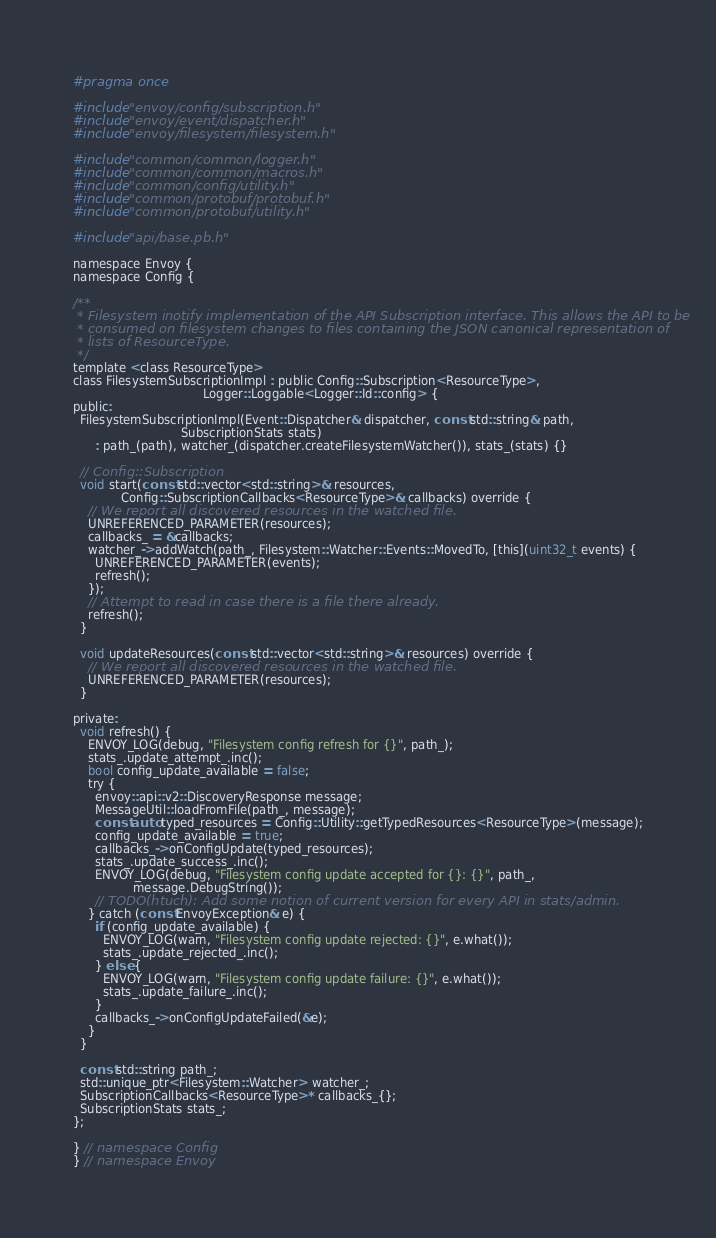Convert code to text. <code><loc_0><loc_0><loc_500><loc_500><_C_>#pragma once

#include "envoy/config/subscription.h"
#include "envoy/event/dispatcher.h"
#include "envoy/filesystem/filesystem.h"

#include "common/common/logger.h"
#include "common/common/macros.h"
#include "common/config/utility.h"
#include "common/protobuf/protobuf.h"
#include "common/protobuf/utility.h"

#include "api/base.pb.h"

namespace Envoy {
namespace Config {

/**
 * Filesystem inotify implementation of the API Subscription interface. This allows the API to be
 * consumed on filesystem changes to files containing the JSON canonical representation of
 * lists of ResourceType.
 */
template <class ResourceType>
class FilesystemSubscriptionImpl : public Config::Subscription<ResourceType>,
                                   Logger::Loggable<Logger::Id::config> {
public:
  FilesystemSubscriptionImpl(Event::Dispatcher& dispatcher, const std::string& path,
                             SubscriptionStats stats)
      : path_(path), watcher_(dispatcher.createFilesystemWatcher()), stats_(stats) {}

  // Config::Subscription
  void start(const std::vector<std::string>& resources,
             Config::SubscriptionCallbacks<ResourceType>& callbacks) override {
    // We report all discovered resources in the watched file.
    UNREFERENCED_PARAMETER(resources);
    callbacks_ = &callbacks;
    watcher_->addWatch(path_, Filesystem::Watcher::Events::MovedTo, [this](uint32_t events) {
      UNREFERENCED_PARAMETER(events);
      refresh();
    });
    // Attempt to read in case there is a file there already.
    refresh();
  }

  void updateResources(const std::vector<std::string>& resources) override {
    // We report all discovered resources in the watched file.
    UNREFERENCED_PARAMETER(resources);
  }

private:
  void refresh() {
    ENVOY_LOG(debug, "Filesystem config refresh for {}", path_);
    stats_.update_attempt_.inc();
    bool config_update_available = false;
    try {
      envoy::api::v2::DiscoveryResponse message;
      MessageUtil::loadFromFile(path_, message);
      const auto typed_resources = Config::Utility::getTypedResources<ResourceType>(message);
      config_update_available = true;
      callbacks_->onConfigUpdate(typed_resources);
      stats_.update_success_.inc();
      ENVOY_LOG(debug, "Filesystem config update accepted for {}: {}", path_,
                message.DebugString());
      // TODO(htuch): Add some notion of current version for every API in stats/admin.
    } catch (const EnvoyException& e) {
      if (config_update_available) {
        ENVOY_LOG(warn, "Filesystem config update rejected: {}", e.what());
        stats_.update_rejected_.inc();
      } else {
        ENVOY_LOG(warn, "Filesystem config update failure: {}", e.what());
        stats_.update_failure_.inc();
      }
      callbacks_->onConfigUpdateFailed(&e);
    }
  }

  const std::string path_;
  std::unique_ptr<Filesystem::Watcher> watcher_;
  SubscriptionCallbacks<ResourceType>* callbacks_{};
  SubscriptionStats stats_;
};

} // namespace Config
} // namespace Envoy
</code> 